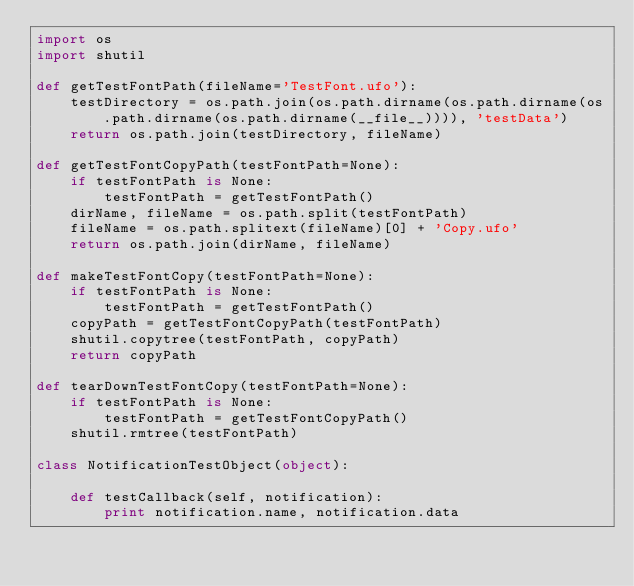<code> <loc_0><loc_0><loc_500><loc_500><_Python_>import os
import shutil

def getTestFontPath(fileName='TestFont.ufo'):
    testDirectory = os.path.join(os.path.dirname(os.path.dirname(os.path.dirname(os.path.dirname(__file__)))), 'testData')
    return os.path.join(testDirectory, fileName)

def getTestFontCopyPath(testFontPath=None):
    if testFontPath is None:
        testFontPath = getTestFontPath()
    dirName, fileName = os.path.split(testFontPath)
    fileName = os.path.splitext(fileName)[0] + 'Copy.ufo'
    return os.path.join(dirName, fileName)

def makeTestFontCopy(testFontPath=None):
    if testFontPath is None:
        testFontPath = getTestFontPath()
    copyPath = getTestFontCopyPath(testFontPath)
    shutil.copytree(testFontPath, copyPath)
    return copyPath

def tearDownTestFontCopy(testFontPath=None):
    if testFontPath is None:
        testFontPath = getTestFontCopyPath()
    shutil.rmtree(testFontPath)

class NotificationTestObject(object):
    
    def testCallback(self, notification):
        print notification.name, notification.data</code> 